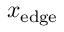<formula> <loc_0><loc_0><loc_500><loc_500>x _ { e d g e }</formula> 